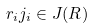<formula> <loc_0><loc_0><loc_500><loc_500>r _ { i } j _ { i } \in J ( R )</formula> 